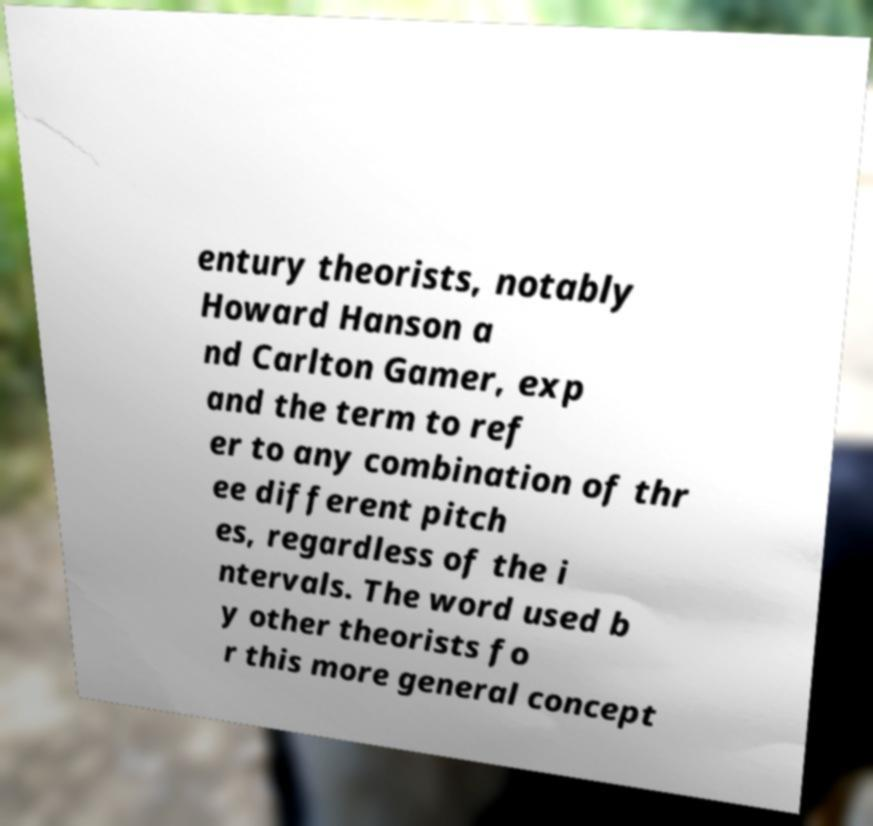I need the written content from this picture converted into text. Can you do that? entury theorists, notably Howard Hanson a nd Carlton Gamer, exp and the term to ref er to any combination of thr ee different pitch es, regardless of the i ntervals. The word used b y other theorists fo r this more general concept 